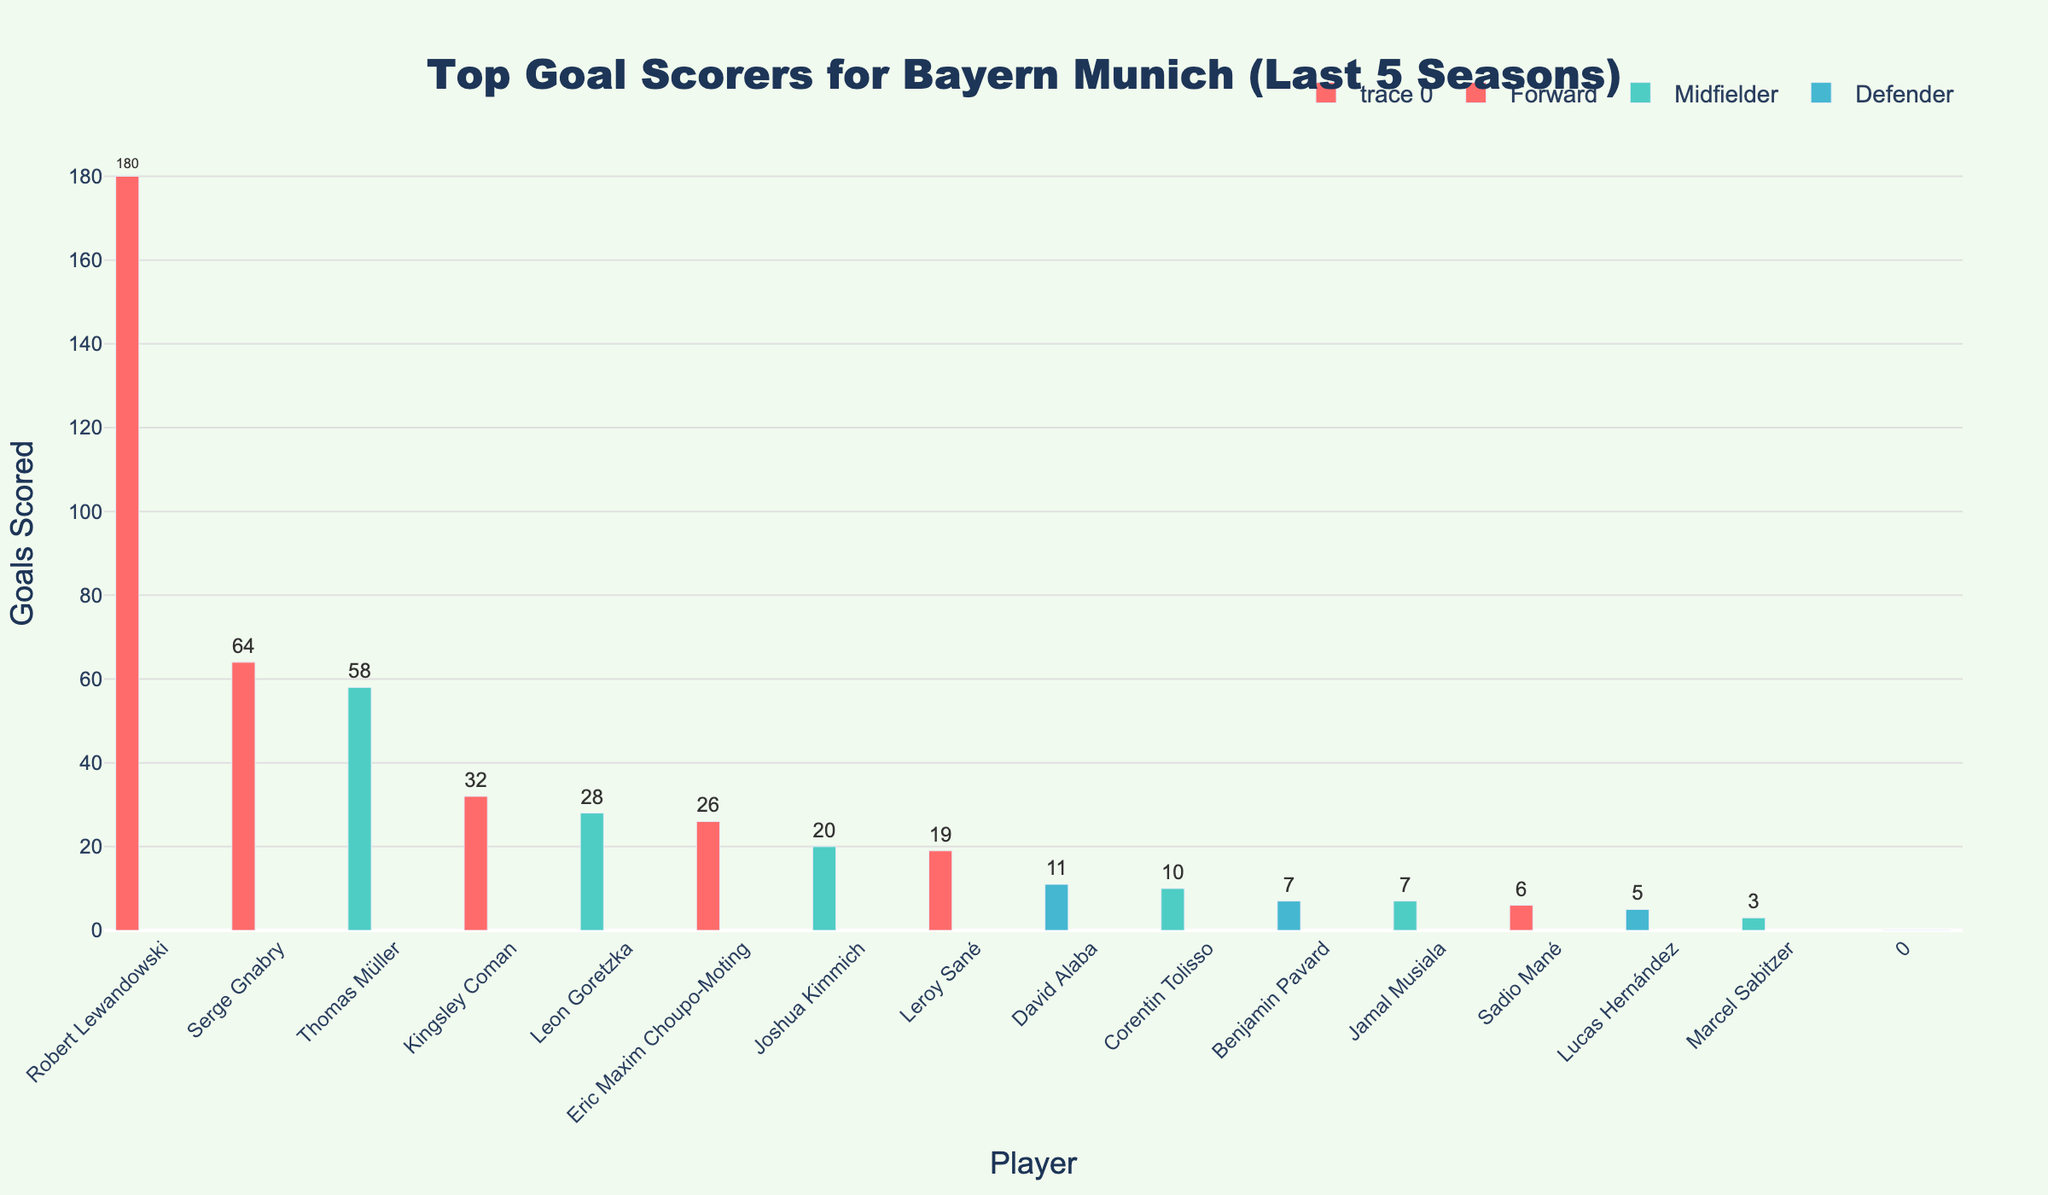Which player scored the most goals in the last 5 seasons? The player who scored the most goals is the one with the highest bar in the chart. Robert Lewandowski's bar is the tallest, indicating he scored the most goals.
Answer: Robert Lewandowski How many goals did all the midfielders score combined? Add the goals scored by all midfielders: Thomas Müller (58), Leon Goretzka (28), Joshua Kimmich (20), Corentin Tolisso (10), Jamal Musiala (7), Marcel Sabitzer (3). The total is 58 + 28 + 20 + 10 + 7 + 3 = 126.
Answer: 126 Who scored more goals, Kingsley Coman or Thomas Müller? Compare the height of the bars for Kingsley Coman and Thomas Müller. Thomas Müller's bar is taller with 58 goals, while Kingsley Coman scored 32.
Answer: Thomas Müller Which position contributed the most goals overall? Sum the goals of players by each position: Forwards: 180+64+32+26+19+6 = 327; Midfielders: 58+28+20+10+7+3 = 126; Defenders: 11+7+5 = 23. Forward scored 327 goals which is the highest.
Answer: Forward How many more goals did Robert Lewandowski score compared to Serge Gnabry? Subtract the number of goals scored by Serge Gnabry from Robert Lewandowski: 180 - 64 = 116.
Answer: 116 Between the defenders, who scored the least goals? Compare the bars for the defenders: David Alaba (11), Benjamin Pavard (7), Lucas Hernández (5). Lucas Hernández's bar is the shortest.
Answer: Lucas Hernández What is the average number of goals scored by the players? Sum the goals of all players and divide by the number of players: (180+64+58+32+28+26+20+19+11+10+7+7+6+5+3) / 15 = 476 / 15 ≈ 31.7.
Answer: 31.7 Which midfielder scored almost the same number of goals as Kingsley Coman? Compare midfielders' bars to Kingsley Coman’s bar (32 goals). Leon Goretzka with 28 goals has a similar, but slightly lower, total.
Answer: Leon Goretzka Which player's bar is green and scored 20 goals? Identify the player with a green bar (indicating a midfielder) who scored 20 goals: Joshua Kimmich.
Answer: Joshua Kimmich How many goals did defenders contribute to the total? Sum the goals of all defenders: David Alaba (11), Benjamin Pavard (7), Lucas Hernández (5). The total is 11 + 7 + 5 = 23.
Answer: 23 